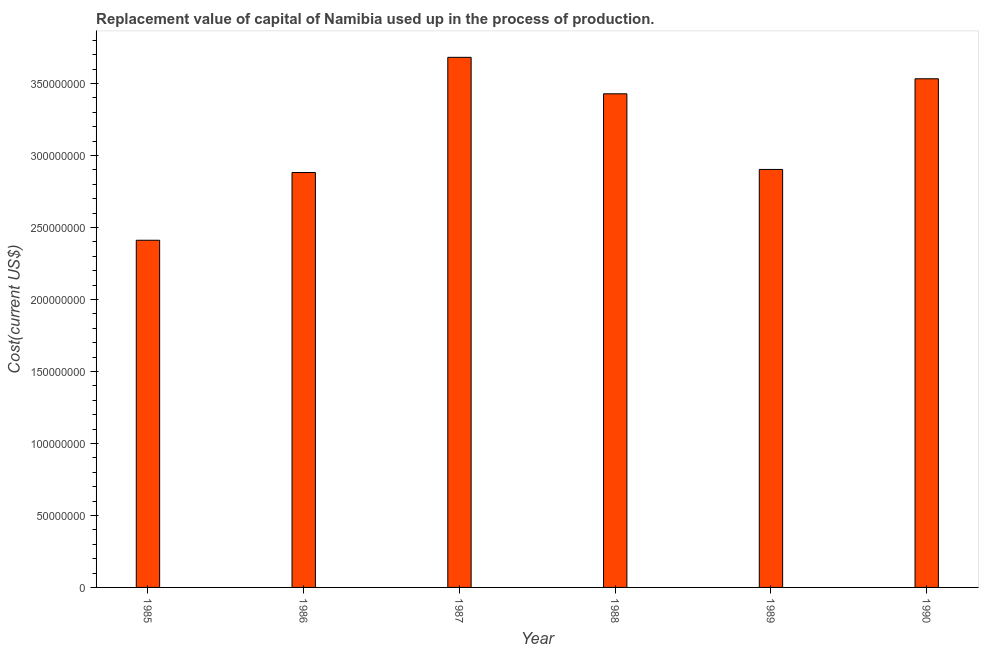Does the graph contain any zero values?
Provide a short and direct response. No. What is the title of the graph?
Your answer should be compact. Replacement value of capital of Namibia used up in the process of production. What is the label or title of the Y-axis?
Your response must be concise. Cost(current US$). What is the consumption of fixed capital in 1990?
Ensure brevity in your answer.  3.53e+08. Across all years, what is the maximum consumption of fixed capital?
Offer a very short reply. 3.68e+08. Across all years, what is the minimum consumption of fixed capital?
Keep it short and to the point. 2.41e+08. In which year was the consumption of fixed capital maximum?
Provide a short and direct response. 1987. In which year was the consumption of fixed capital minimum?
Make the answer very short. 1985. What is the sum of the consumption of fixed capital?
Provide a succinct answer. 1.88e+09. What is the difference between the consumption of fixed capital in 1986 and 1989?
Ensure brevity in your answer.  -2.13e+06. What is the average consumption of fixed capital per year?
Provide a short and direct response. 3.14e+08. What is the median consumption of fixed capital?
Provide a short and direct response. 3.17e+08. In how many years, is the consumption of fixed capital greater than 100000000 US$?
Give a very brief answer. 6. What is the ratio of the consumption of fixed capital in 1985 to that in 1987?
Make the answer very short. 0.66. Is the consumption of fixed capital in 1988 less than that in 1989?
Keep it short and to the point. No. What is the difference between the highest and the second highest consumption of fixed capital?
Make the answer very short. 1.49e+07. What is the difference between the highest and the lowest consumption of fixed capital?
Your answer should be very brief. 1.27e+08. Are all the bars in the graph horizontal?
Your response must be concise. No. What is the Cost(current US$) of 1985?
Ensure brevity in your answer.  2.41e+08. What is the Cost(current US$) of 1986?
Keep it short and to the point. 2.88e+08. What is the Cost(current US$) of 1987?
Offer a terse response. 3.68e+08. What is the Cost(current US$) of 1988?
Offer a very short reply. 3.43e+08. What is the Cost(current US$) in 1989?
Provide a succinct answer. 2.90e+08. What is the Cost(current US$) of 1990?
Give a very brief answer. 3.53e+08. What is the difference between the Cost(current US$) in 1985 and 1986?
Provide a short and direct response. -4.71e+07. What is the difference between the Cost(current US$) in 1985 and 1987?
Give a very brief answer. -1.27e+08. What is the difference between the Cost(current US$) in 1985 and 1988?
Your answer should be very brief. -1.02e+08. What is the difference between the Cost(current US$) in 1985 and 1989?
Make the answer very short. -4.92e+07. What is the difference between the Cost(current US$) in 1985 and 1990?
Give a very brief answer. -1.12e+08. What is the difference between the Cost(current US$) in 1986 and 1987?
Ensure brevity in your answer.  -8.00e+07. What is the difference between the Cost(current US$) in 1986 and 1988?
Provide a succinct answer. -5.47e+07. What is the difference between the Cost(current US$) in 1986 and 1989?
Provide a short and direct response. -2.13e+06. What is the difference between the Cost(current US$) in 1986 and 1990?
Your response must be concise. -6.51e+07. What is the difference between the Cost(current US$) in 1987 and 1988?
Provide a succinct answer. 2.53e+07. What is the difference between the Cost(current US$) in 1987 and 1989?
Your answer should be very brief. 7.79e+07. What is the difference between the Cost(current US$) in 1987 and 1990?
Your response must be concise. 1.49e+07. What is the difference between the Cost(current US$) in 1988 and 1989?
Your answer should be compact. 5.25e+07. What is the difference between the Cost(current US$) in 1988 and 1990?
Give a very brief answer. -1.04e+07. What is the difference between the Cost(current US$) in 1989 and 1990?
Your response must be concise. -6.30e+07. What is the ratio of the Cost(current US$) in 1985 to that in 1986?
Offer a very short reply. 0.84. What is the ratio of the Cost(current US$) in 1985 to that in 1987?
Your answer should be very brief. 0.66. What is the ratio of the Cost(current US$) in 1985 to that in 1988?
Your answer should be compact. 0.7. What is the ratio of the Cost(current US$) in 1985 to that in 1989?
Keep it short and to the point. 0.83. What is the ratio of the Cost(current US$) in 1985 to that in 1990?
Offer a terse response. 0.68. What is the ratio of the Cost(current US$) in 1986 to that in 1987?
Your response must be concise. 0.78. What is the ratio of the Cost(current US$) in 1986 to that in 1988?
Give a very brief answer. 0.84. What is the ratio of the Cost(current US$) in 1986 to that in 1989?
Your response must be concise. 0.99. What is the ratio of the Cost(current US$) in 1986 to that in 1990?
Offer a very short reply. 0.82. What is the ratio of the Cost(current US$) in 1987 to that in 1988?
Make the answer very short. 1.07. What is the ratio of the Cost(current US$) in 1987 to that in 1989?
Make the answer very short. 1.27. What is the ratio of the Cost(current US$) in 1987 to that in 1990?
Make the answer very short. 1.04. What is the ratio of the Cost(current US$) in 1988 to that in 1989?
Give a very brief answer. 1.18. What is the ratio of the Cost(current US$) in 1988 to that in 1990?
Your answer should be very brief. 0.97. What is the ratio of the Cost(current US$) in 1989 to that in 1990?
Keep it short and to the point. 0.82. 